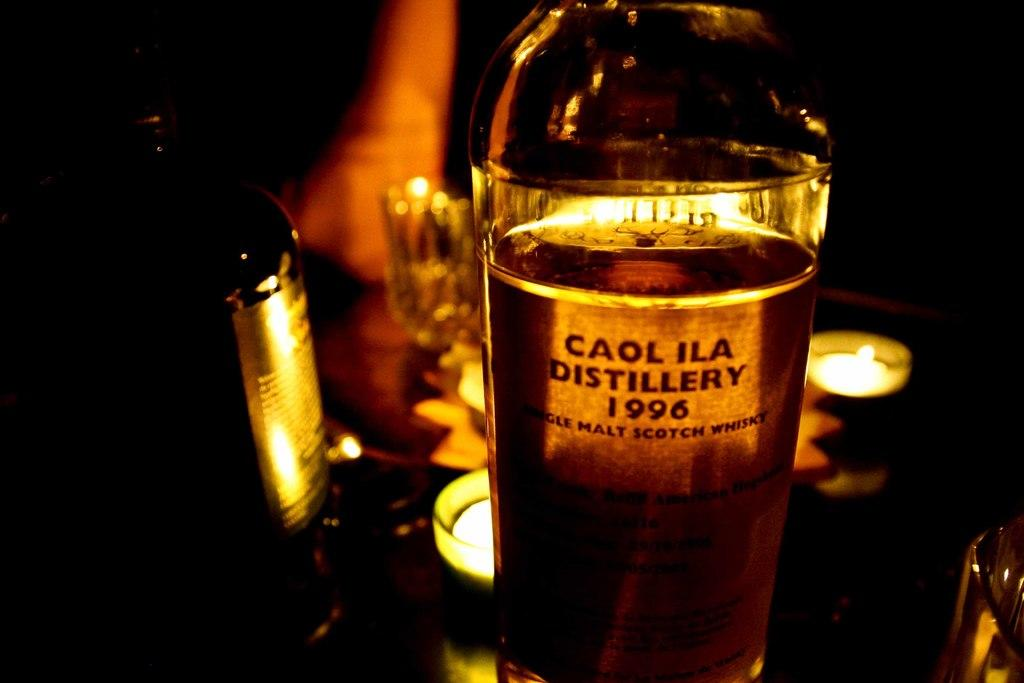<image>
Describe the image concisely. A bottle of liquor from the Caol Ila Distillery. 